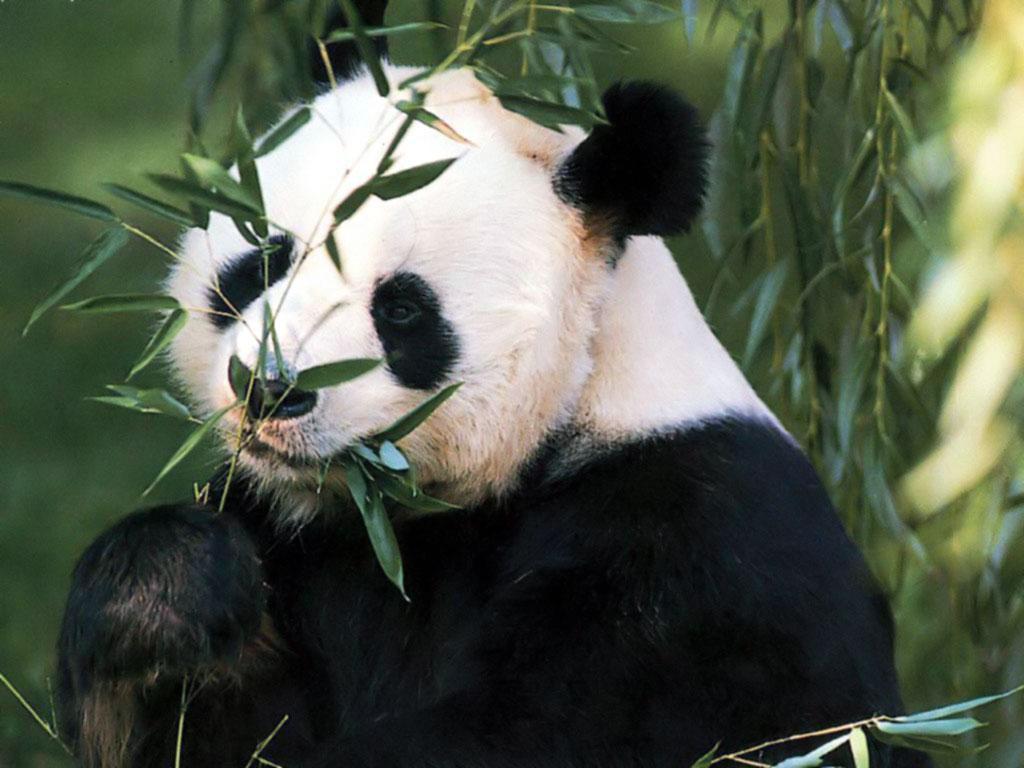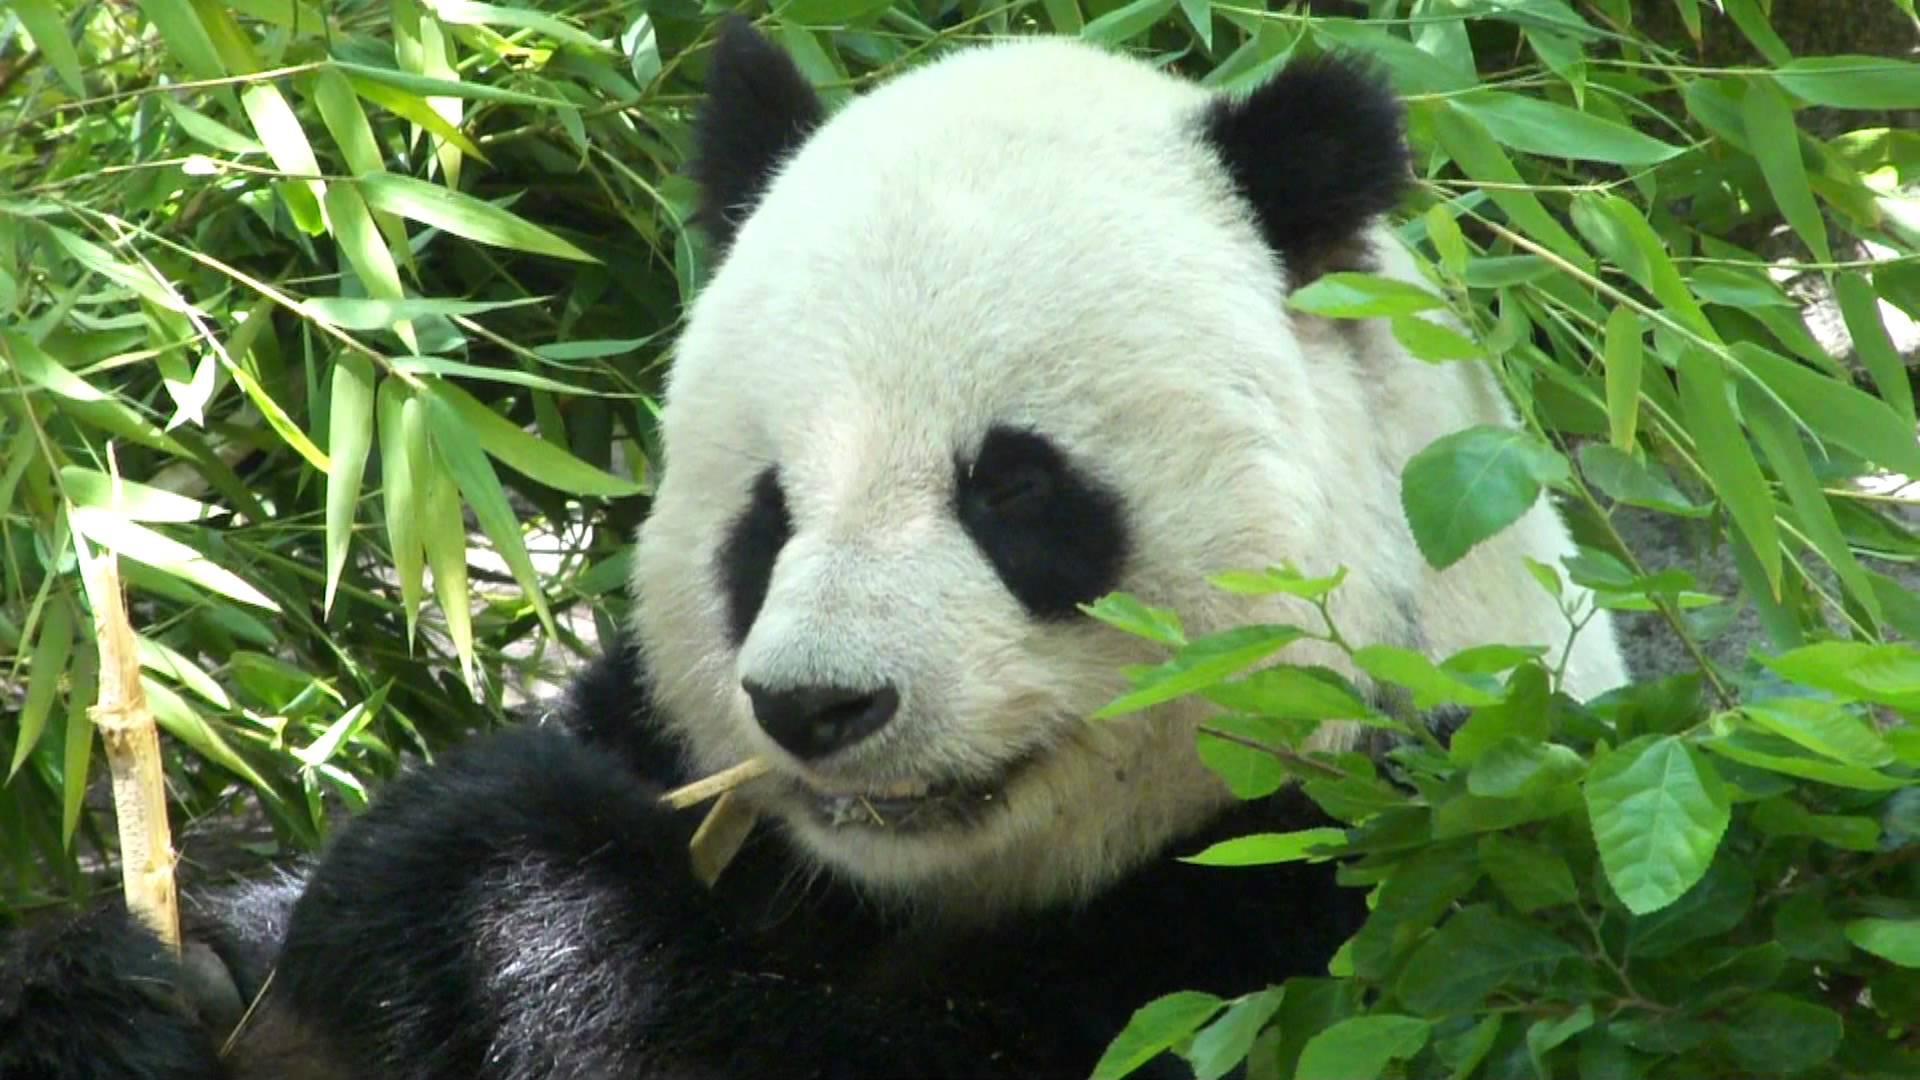The first image is the image on the left, the second image is the image on the right. Evaluate the accuracy of this statement regarding the images: "A shoot in the image on the left is in front of the panda's face.". Is it true? Answer yes or no. Yes. The first image is the image on the left, the second image is the image on the right. Analyze the images presented: Is the assertion "Each image shows one forward-facing panda munching something, but the panda on the left is munching green leaves, while the panda on the right is munching yellow stalks." valid? Answer yes or no. Yes. 